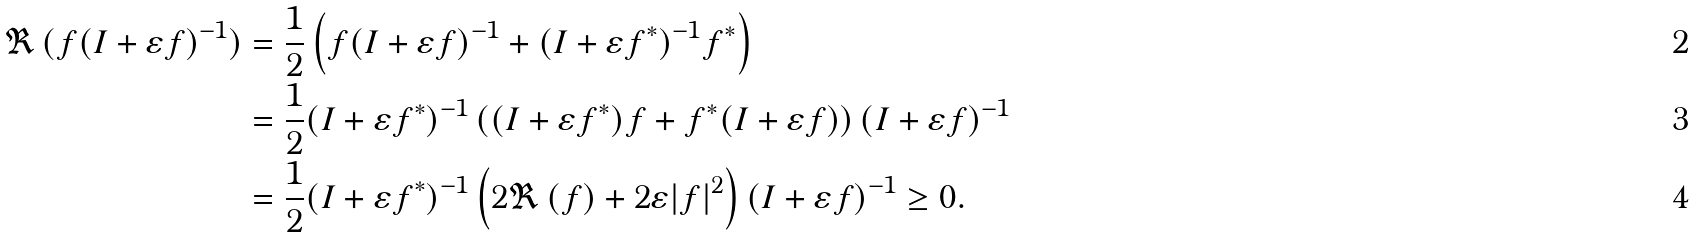<formula> <loc_0><loc_0><loc_500><loc_500>\Re \, ( f ( I + \varepsilon f ) ^ { - 1 } ) & = \frac { 1 } { 2 } \left ( f ( I + \varepsilon f ) ^ { - 1 } + ( I + \varepsilon f ^ { * } ) ^ { - 1 } f ^ { * } \right ) \\ & = \frac { 1 } { 2 } ( I + \varepsilon f ^ { * } ) ^ { - 1 } \left ( ( I + \varepsilon f ^ { * } ) f + f ^ { * } ( I + \varepsilon f ) \right ) ( I + \varepsilon f ) ^ { - 1 } \\ & = \frac { 1 } { 2 } ( I + \varepsilon f ^ { * } ) ^ { - 1 } \left ( 2 \Re \, ( f ) + 2 \varepsilon | f | ^ { 2 } \right ) ( I + \varepsilon f ) ^ { - 1 } \geq 0 .</formula> 